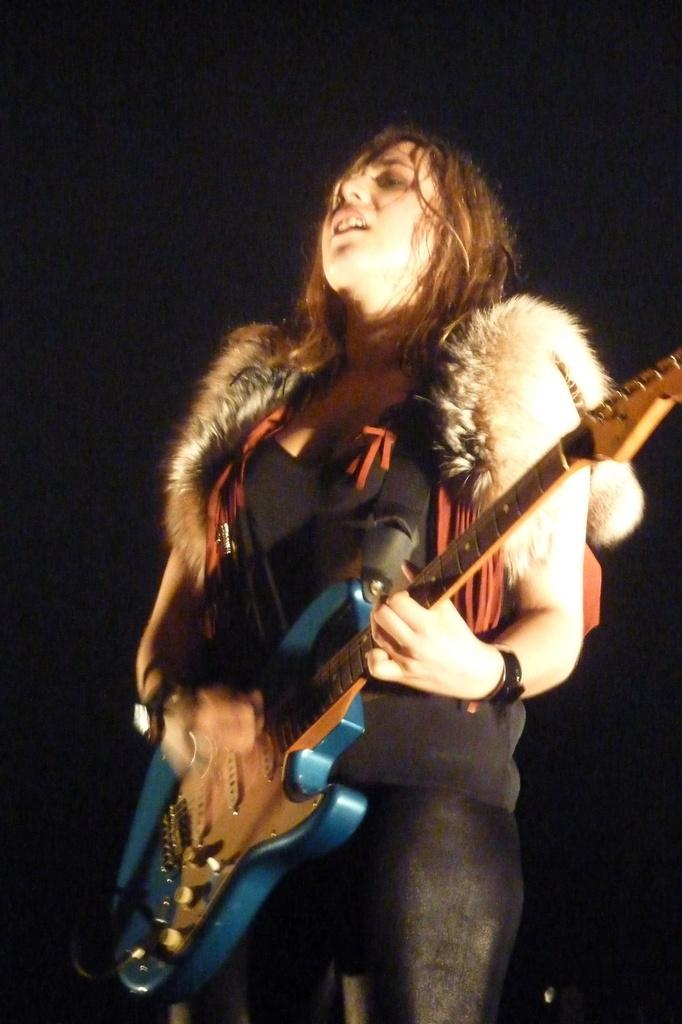What is the main subject of the image? The main subject of the image is a woman. What is the woman holding in the image? The woman is holding a guitar. What type of ornament is hanging from the clouds in the image? There are no clouds or ornaments present in the image; it features a woman holding a guitar. 